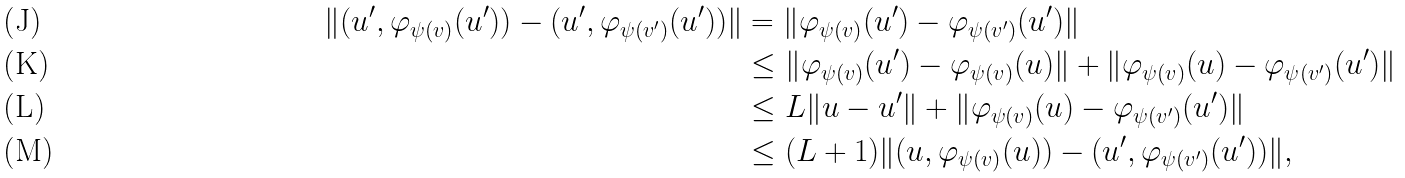<formula> <loc_0><loc_0><loc_500><loc_500>\| ( u ^ { \prime } , \varphi _ { \psi ( v ) } ( u ^ { \prime } ) ) - ( u ^ { \prime } , \varphi _ { \psi ( v ^ { \prime } ) } ( u ^ { \prime } ) ) \| & = \| \varphi _ { \psi ( v ) } ( u ^ { \prime } ) - \varphi _ { \psi ( v ^ { \prime } ) } ( u ^ { \prime } ) \| \\ & \leq \| \varphi _ { \psi ( v ) } ( u ^ { \prime } ) - \varphi _ { \psi ( v ) } ( u ) \| + \| \varphi _ { \psi ( v ) } ( u ) - \varphi _ { \psi ( v ^ { \prime } ) } ( u ^ { \prime } ) \| \\ & \leq L \| u - u ^ { \prime } \| + \| \varphi _ { \psi ( v ) } ( u ) - \varphi _ { \psi ( v ^ { \prime } ) } ( u ^ { \prime } ) \| \\ & \leq ( L + 1 ) \| ( u , \varphi _ { \psi ( v ) } ( u ) ) - ( u ^ { \prime } , \varphi _ { \psi ( v ^ { \prime } ) } ( u ^ { \prime } ) ) \| ,</formula> 